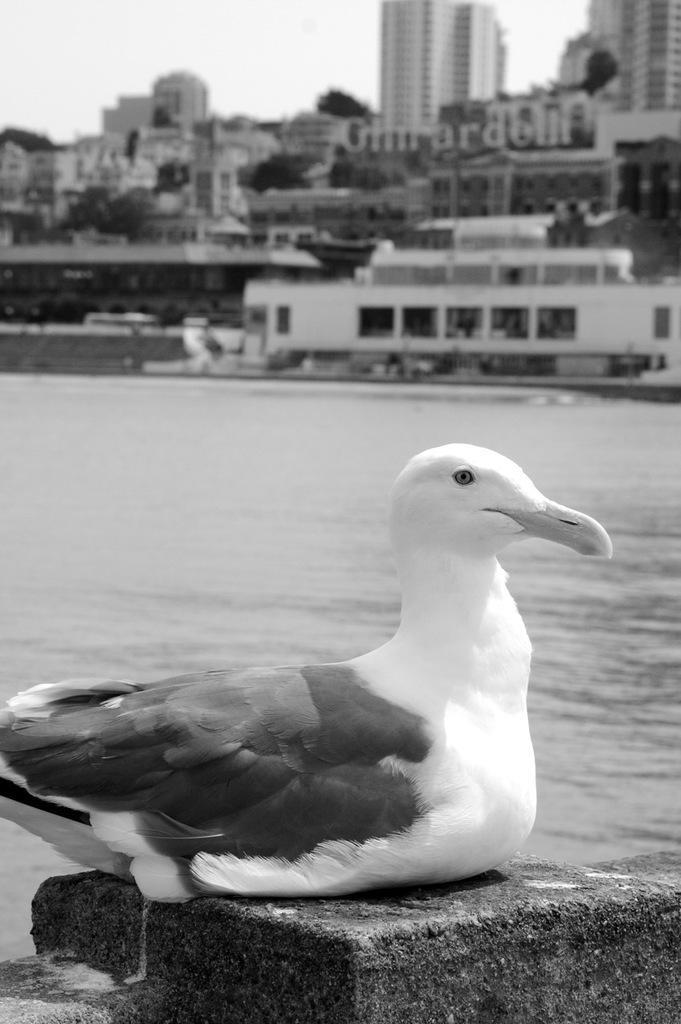Describe this image in one or two sentences. In this picture we can observe a duck sitting on the wall. In the background there is a river. We can observe some buildings and trees. This is a black and white image. 